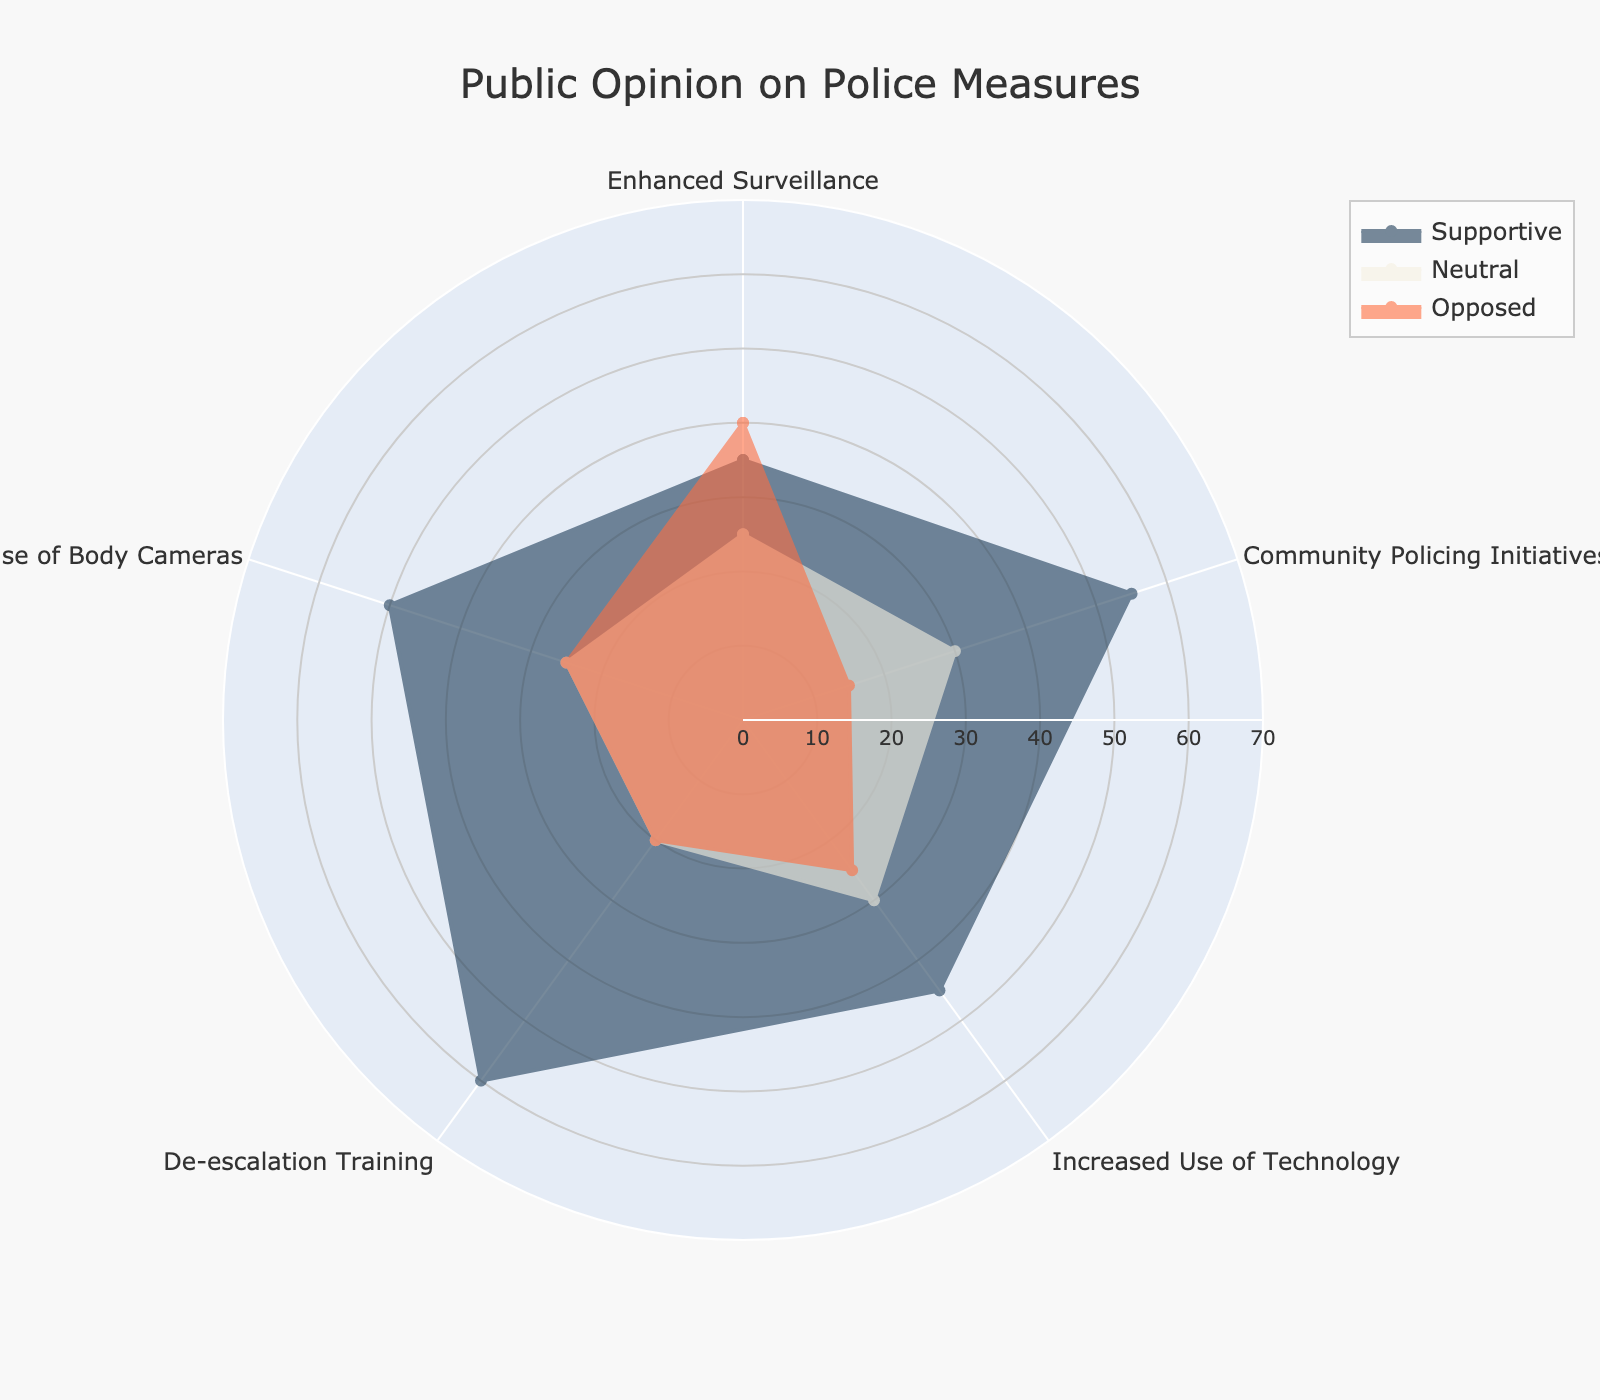what's the title of the figure? The title is often located at the top center of the figure. For this radar chart, it displays the overview of what the chart represents.
Answer: Public Opinion on Police Measures which group shows the highest support for De-escalation Training? To find this, look at the De-escalation Training point on the radar chart and see which group has the highest value.
Answer: Supportive how many categories are evaluated in this chart? Count the number of different police measures listed.
Answer: 5 which police measure has the least opposition? Look at the 'Opposed' group's values for each police measure and identify the lowest value.
Answer: Community Policing Initiatives which category shows equal values for the Neutral and Opposed groups? Find if there is a category where the values for Neutral and Opposed groups coincide. This requires comparing values across each category.
Answer: Use of Body Cameras what is the difference in support between Enhanced Surveillance and Community Policing Initiatives? Subtract the Supportive value for Enhanced Surveillance from the Supportive value for Community Policing Initiatives.
Answer: 20 which group has the lowest average value across all categories? Calculate the average for each group by summing their values across all categories and dividing by the number of categories, then find the lowest.
Answer: Neutral how does the support for Increased Use of Technology compare to the support for Enhanced Surveillance? Compare the Supportive values for both Increased Use of Technology and Enhanced Surveillance.
Answer: 10 higher what's the overall trend in the level of opposition for all measures? Evaluate the opposition group's values across all categories to find any trends or patterns.
Answer: Mostly balanced, with Community Policing Initiatives notably lower which police measure has the similar support and opposition percentages? Identify a police measure where the values for Supportive and Opposed groups are alike or very close.
Answer: Use of Body Cameras 